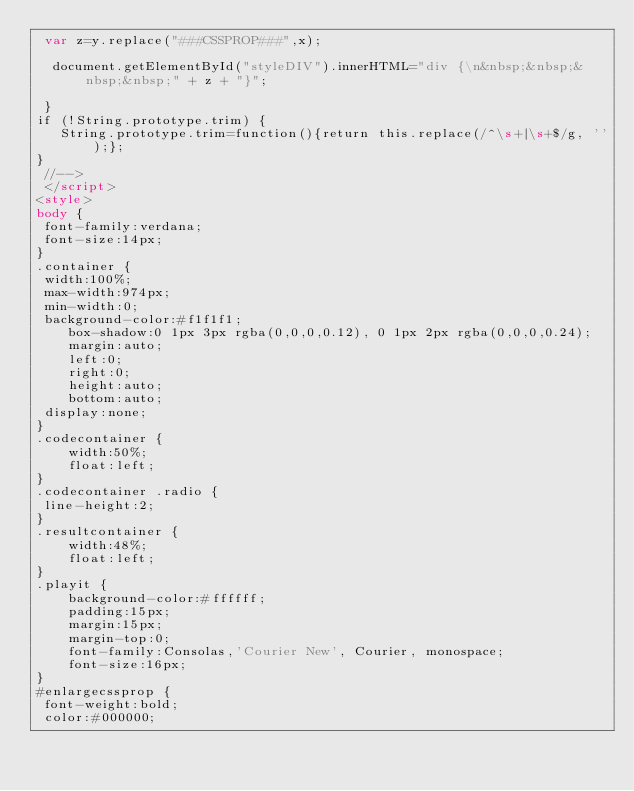Convert code to text. <code><loc_0><loc_0><loc_500><loc_500><_HTML_> var z=y.replace("###CSSPROP###",x);
 
  document.getElementById("styleDIV").innerHTML="div {\n&nbsp;&nbsp;&nbsp;&nbsp;" + z + "}";
 
 }
if (!String.prototype.trim) {
   String.prototype.trim=function(){return this.replace(/^\s+|\s+$/g, '');};
} 
 //-->
 </script>
<style> 
body {
 font-family:verdana;
 font-size:14px;
}
.container {
 width:100%;
 max-width:974px;
 min-width:0;
 background-color:#f1f1f1;
    box-shadow:0 1px 3px rgba(0,0,0,0.12), 0 1px 2px rgba(0,0,0,0.24);
    margin:auto;
    left:0;
    right:0;
    height:auto;
    bottom:auto;
 display:none;
}
.codecontainer {
    width:50%;
    float:left;
}
.codecontainer .radio {
 line-height:2;
}
.resultcontainer {
    width:48%;
    float:left;
}
.playit {
    background-color:#ffffff;
    padding:15px;
    margin:15px;
    margin-top:0;
    font-family:Consolas,'Courier New', Courier, monospace;
    font-size:16px;
}
#enlargecssprop {
 font-weight:bold;
 color:#000000;</code> 